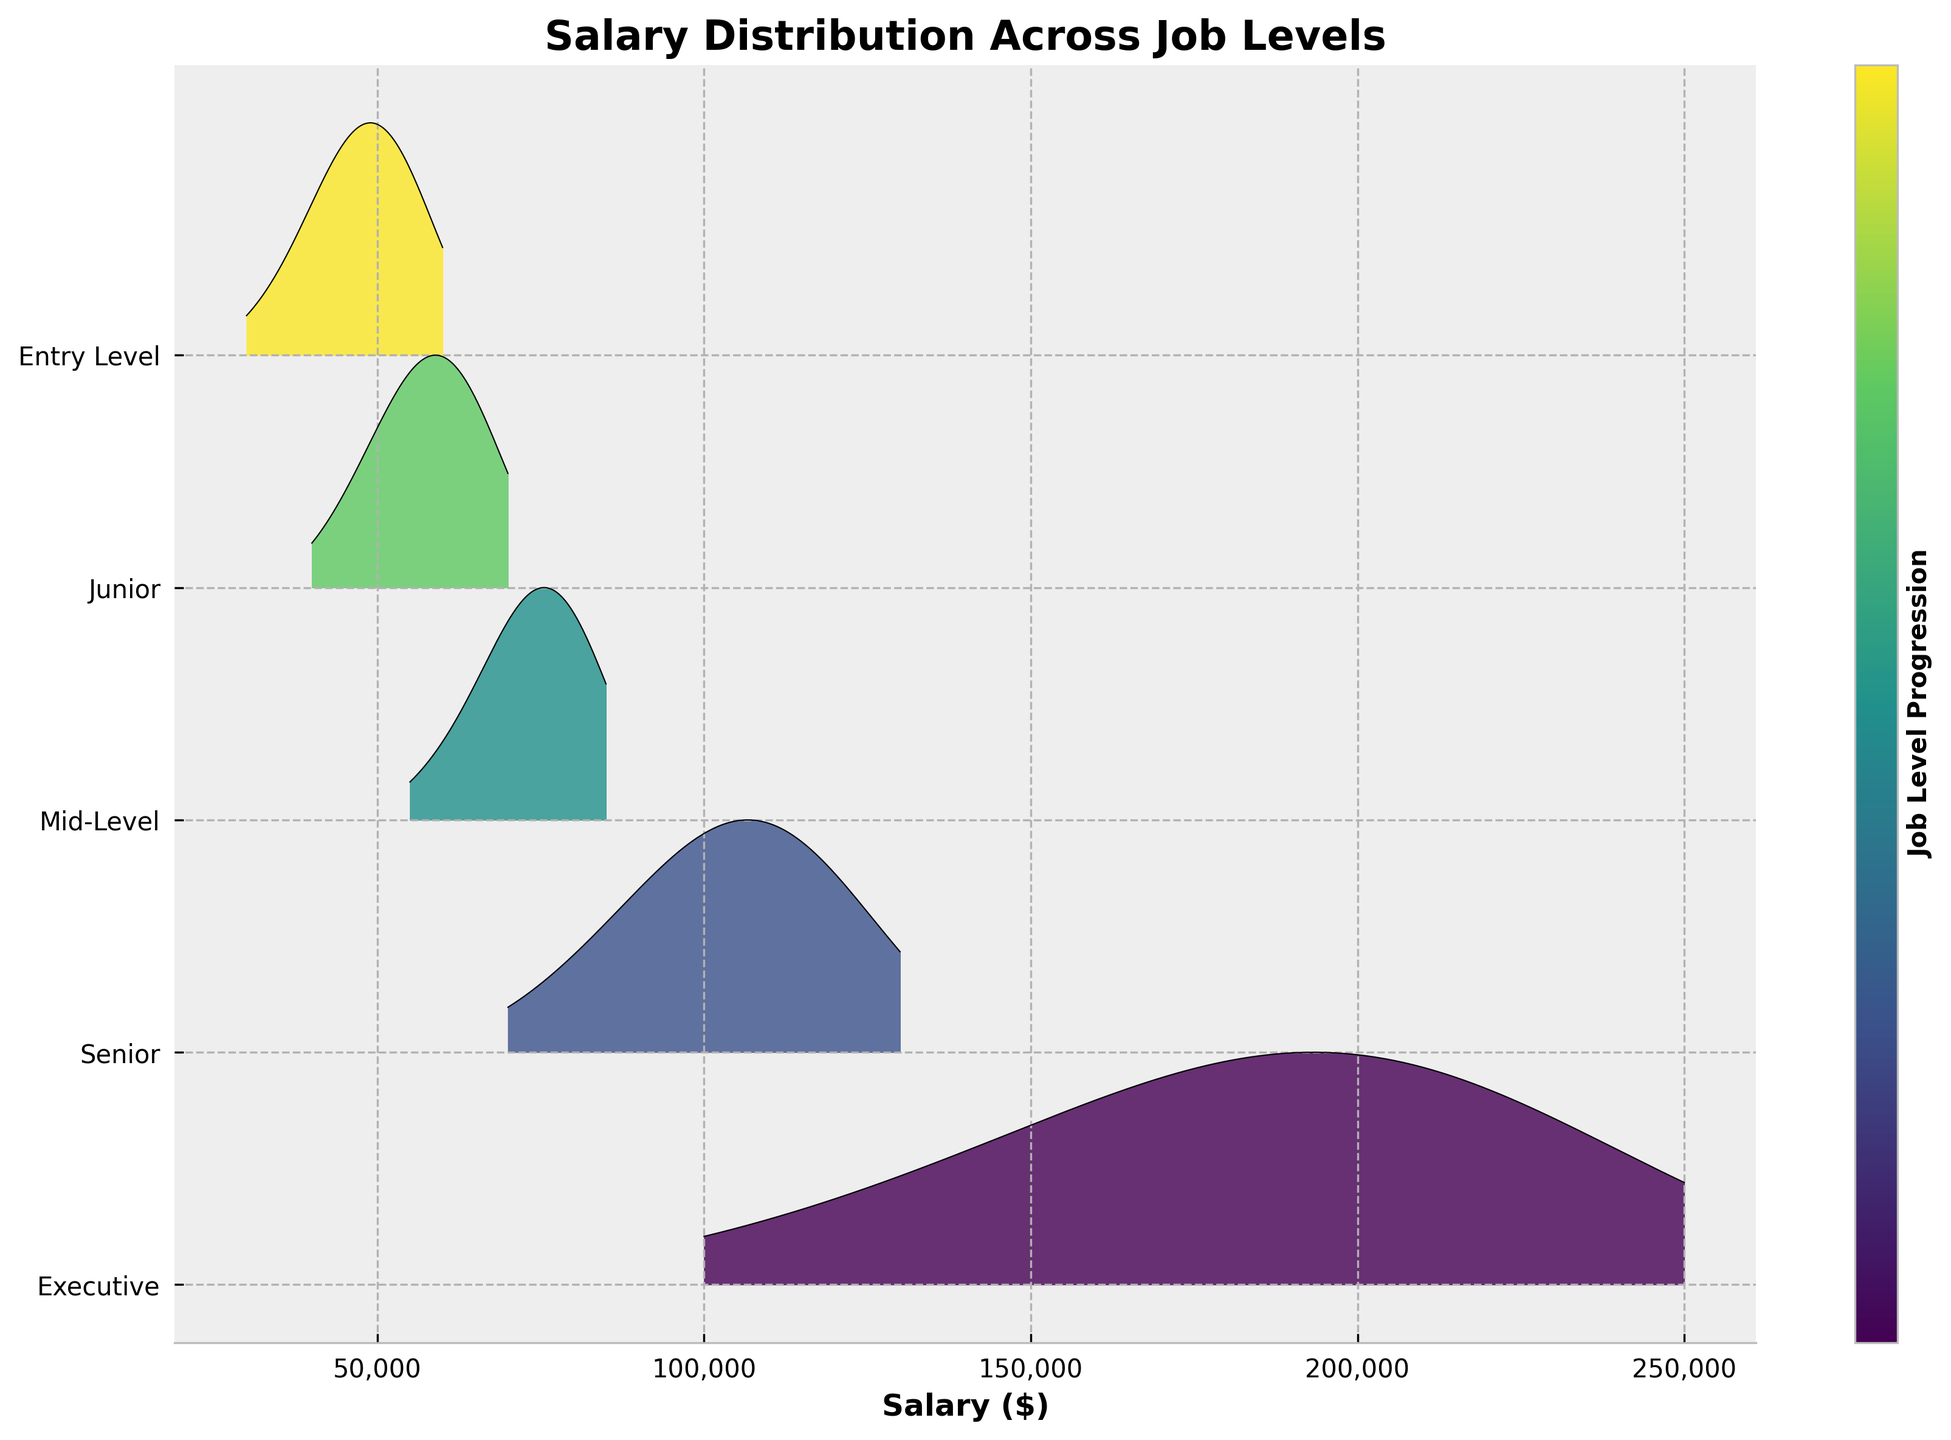Which job level has the highest salary density at $65,000? To find this, look for the line representing $65,000 on the ridgeline plot. The Junior job level has a visible density peak near this salary.
Answer: Junior Which job level shows the widest range of salaries? The Executive job level shows the widest range of salaries, spanning from $100,000 to $250,000. This can be observed by examining the horizontal spread of each job level’s distribution.
Answer: Executive Which job level has a higher density at $60,000, Entry Level or Junior? By comparing the density heights at $60,000 for Entry Level and Junior job levels, the Junior level shows a higher peak.
Answer: Junior What is the common salary range overlapping between the Mid-Level and Senior? To find the overlapping range, look at where the distributions of Mid-Level and Senior job levels start and end. The common range is around $70,000 to $85,000.
Answer: $70,000 to $85,000 What job level has the highest salary density peak overall, and at what salary does it occur? The highest density peak overall is observed for the Senior job level, occurring at $110,000. This is determined by comparing the peak heights across all job levels.
Answer: Senior at $110,000 Which job level has a noticeable drop in density beyond $120,000? The Senior job level has a noticeable drop in density beyond $120,000. This can be seen by observing the density line decreasing significantly after this salary point.
Answer: Senior What is the range of salaries for the Entry Level job level? The Entry Level job level ranges from $30,000 to $60,000. This is identified by observing the horizontal span of the distribution for this job level.
Answer: $30,000 to $60,000 How does the salary density trend change from Mid-Level to Executive? The trend changes by expanding both the salary range and peak density values progressively from Mid-Level to Executive levels, indicating higher salaries and variability.
Answer: Expands from lower to higher salaries At which salary does the Junior job level density start to significantly decline? The Junior job level density starts to significantly decline after $70,000. This can be determined by examining where the density visually decreases noticeably.
Answer: After $70,000 What approximate salary corresponds to the peak density for the Executive job level? The peak density for the Executive job level is around $200,000. This is identified by locating the tallest peak for this job level in the plot.
Answer: $200,000 